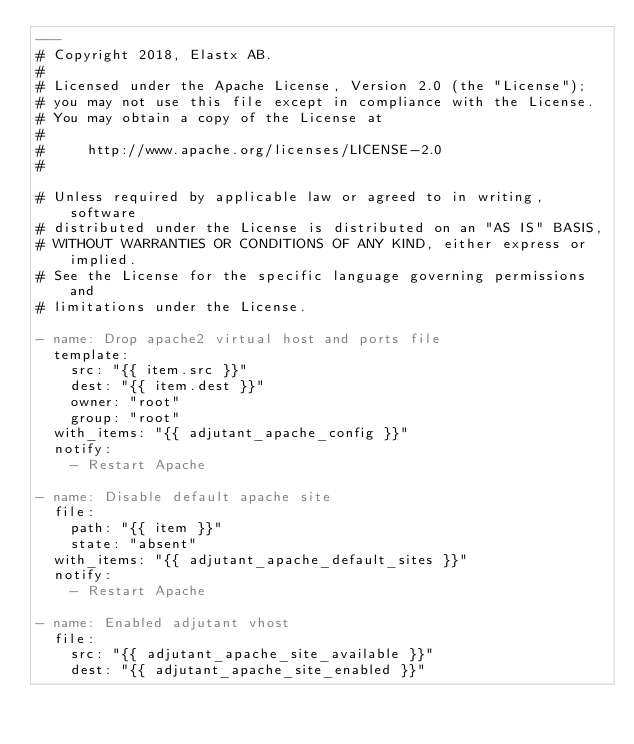<code> <loc_0><loc_0><loc_500><loc_500><_YAML_>---
# Copyright 2018, Elastx AB.
#
# Licensed under the Apache License, Version 2.0 (the "License");
# you may not use this file except in compliance with the License.
# You may obtain a copy of the License at
#
#     http://www.apache.org/licenses/LICENSE-2.0
#

# Unless required by applicable law or agreed to in writing, software
# distributed under the License is distributed on an "AS IS" BASIS,
# WITHOUT WARRANTIES OR CONDITIONS OF ANY KIND, either express or implied.
# See the License for the specific language governing permissions and
# limitations under the License.

- name: Drop apache2 virtual host and ports file
  template:
    src: "{{ item.src }}"
    dest: "{{ item.dest }}"
    owner: "root"
    group: "root"
  with_items: "{{ adjutant_apache_config }}"
  notify:
    - Restart Apache

- name: Disable default apache site
  file:
    path: "{{ item }}"
    state: "absent"
  with_items: "{{ adjutant_apache_default_sites }}"
  notify:
    - Restart Apache

- name: Enabled adjutant vhost
  file:
    src: "{{ adjutant_apache_site_available }}"
    dest: "{{ adjutant_apache_site_enabled }}"</code> 